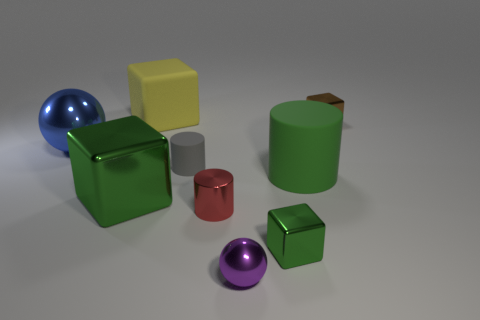Subtract all rubber blocks. How many blocks are left? 3 Subtract all cyan spheres. How many green blocks are left? 2 Subtract all blue spheres. How many spheres are left? 1 Subtract 2 cubes. How many cubes are left? 2 Add 9 gray matte cylinders. How many gray matte cylinders exist? 10 Subtract 0 cyan spheres. How many objects are left? 9 Subtract all cubes. How many objects are left? 5 Subtract all cyan spheres. Subtract all purple cylinders. How many spheres are left? 2 Subtract all large cyan cylinders. Subtract all small purple spheres. How many objects are left? 8 Add 4 cylinders. How many cylinders are left? 7 